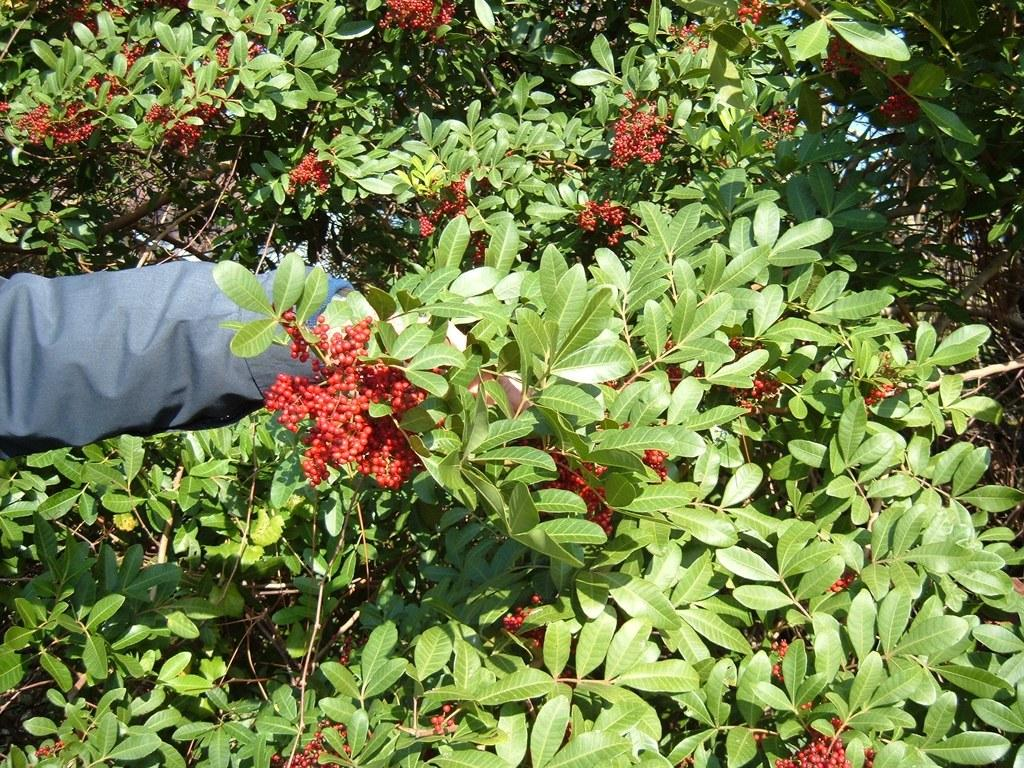What color are the fruits in the image? The fruits in the image are red. What type of vegetation is present in the image? There are green color leaves in the image. What color is the cloth in the image? The cloth in the image is blue. How many kittens are playing with the lock in the image? There are no kittens or locks present in the image. 